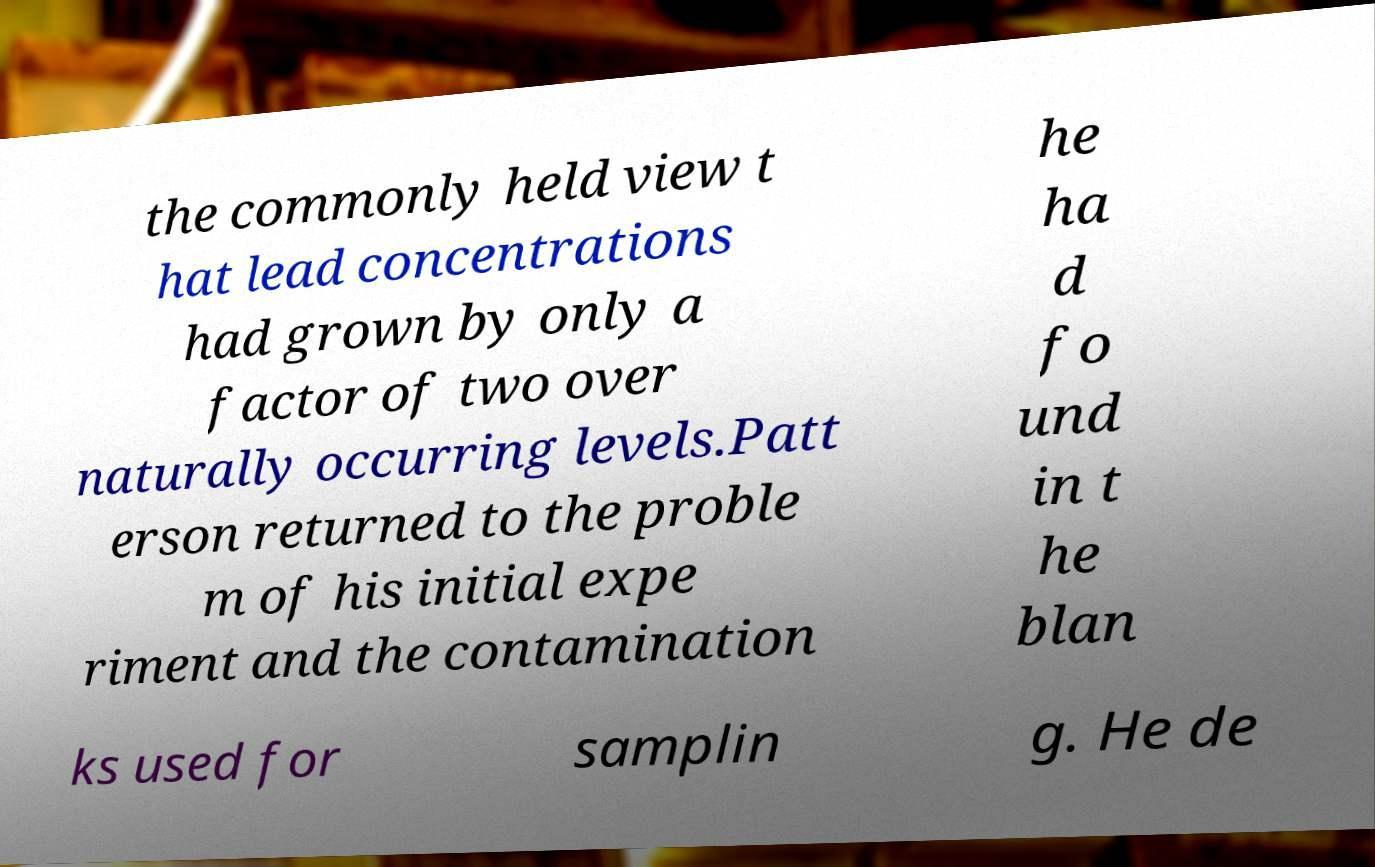Please read and relay the text visible in this image. What does it say? the commonly held view t hat lead concentrations had grown by only a factor of two over naturally occurring levels.Patt erson returned to the proble m of his initial expe riment and the contamination he ha d fo und in t he blan ks used for samplin g. He de 